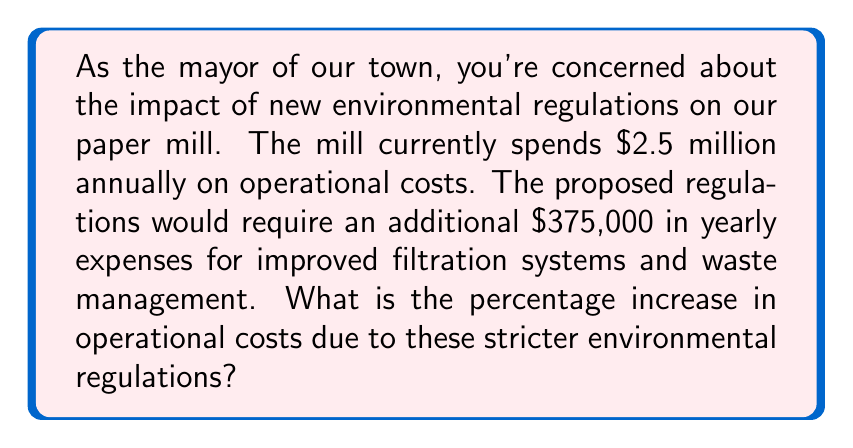Provide a solution to this math problem. To solve this problem, we need to follow these steps:

1. Identify the current operational costs: $2.5 million
2. Identify the additional costs due to new regulations: $375,000
3. Calculate the new total operational costs
4. Calculate the percentage increase

Let's go through each step:

1. Current operational costs: $2.5 million

2. Additional costs: $375,000

3. New total operational costs:
   $$2,500,000 + 375,000 = 2,875,000$$

4. To calculate the percentage increase, we use the formula:
   $$\text{Percentage Increase} = \frac{\text{Increase}}{\text{Original}} \times 100\%$$

   Where:
   Increase = New costs - Original costs
   $$375,000 = 2,875,000 - 2,500,000$$

   So:
   $$\text{Percentage Increase} = \frac{375,000}{2,500,000} \times 100\%$$
   
   $$= 0.15 \times 100\% = 15\%$$

Therefore, the percentage increase in operational costs due to the stricter environmental regulations is 15%.
Answer: 15% 